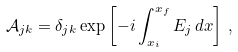Convert formula to latex. <formula><loc_0><loc_0><loc_500><loc_500>\mathcal { A } _ { j k } = \delta _ { j k } \exp \left [ - i \int _ { x _ { i } } ^ { x _ { f } } E _ { j } \, d x \right ] \, ,</formula> 